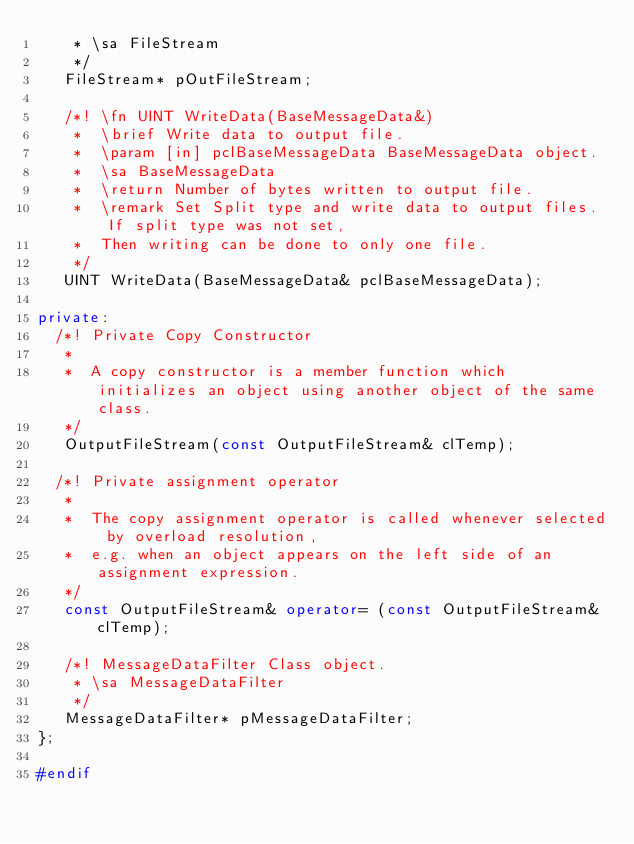Convert code to text. <code><loc_0><loc_0><loc_500><loc_500><_C++_>    * \sa FileStream
    */ 
   FileStream* pOutFileStream;

   /*! \fn UINT WriteData(BaseMessageData&)
    *  \brief Write data to output file.
    *  \param [in] pclBaseMessageData BaseMessageData object.
    *  \sa BaseMessageData
    *  \return Number of bytes written to output file.
    *  \remark Set Split type and write data to output files. If split type was not set,
    *  Then writing can be done to only one file. 
    */ 
   UINT WriteData(BaseMessageData& pclBaseMessageData);

private:
	/*! Private Copy Constructor 
	 *
	 *  A copy constructor is a member function which initializes an object using another object of the same class. 
	 */
   OutputFileStream(const OutputFileStream& clTemp);

	/*! Private assignment operator 
	 *
	 *  The copy assignment operator is called whenever selected by overload resolution, 
	 *  e.g. when an object appears on the left side of an assignment expression.
	 */
   const OutputFileStream& operator= (const OutputFileStream& clTemp);

   /*! MessageDataFilter Class object.
    * \sa MessageDataFilter
    */ 
   MessageDataFilter* pMessageDataFilter;
};

#endif
</code> 